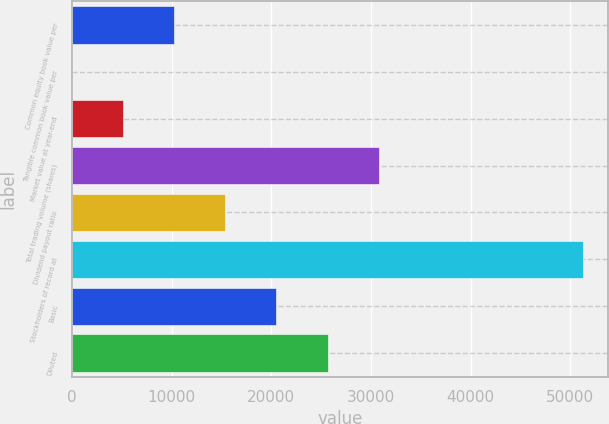Convert chart. <chart><loc_0><loc_0><loc_500><loc_500><bar_chart><fcel>Common equity book value per<fcel>Tangible common book value per<fcel>Market value at year-end<fcel>Total trading volume (shares)<fcel>Dividend payout ratio<fcel>Stockholders of record at<fcel>Basic<fcel>Diluted<nl><fcel>10260.8<fcel>8.52<fcel>5134.67<fcel>30765.4<fcel>15387<fcel>51270<fcel>20513.1<fcel>25639.3<nl></chart> 